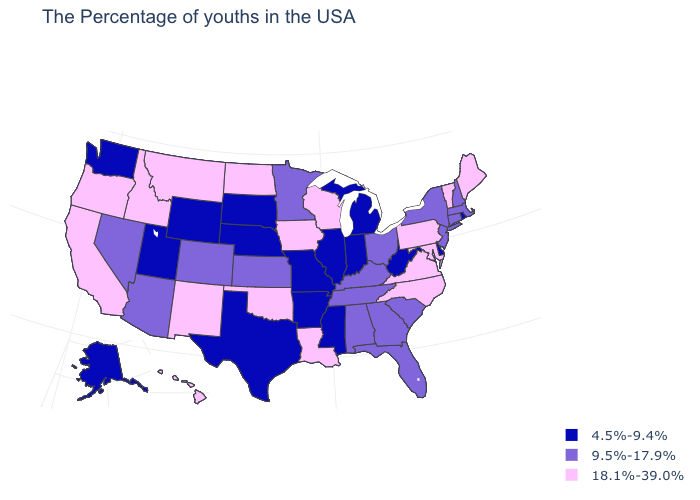Among the states that border Utah , which have the highest value?
Short answer required. New Mexico, Idaho. Among the states that border Connecticut , which have the highest value?
Give a very brief answer. Massachusetts, New York. Does the first symbol in the legend represent the smallest category?
Give a very brief answer. Yes. Does Georgia have a higher value than Nebraska?
Short answer required. Yes. Does Mississippi have the lowest value in the USA?
Answer briefly. Yes. Name the states that have a value in the range 9.5%-17.9%?
Write a very short answer. Massachusetts, New Hampshire, Connecticut, New York, New Jersey, South Carolina, Ohio, Florida, Georgia, Kentucky, Alabama, Tennessee, Minnesota, Kansas, Colorado, Arizona, Nevada. Does Wyoming have a lower value than Illinois?
Keep it brief. No. What is the highest value in states that border Mississippi?
Be succinct. 18.1%-39.0%. Does Illinois have the highest value in the USA?
Quick response, please. No. Name the states that have a value in the range 18.1%-39.0%?
Concise answer only. Maine, Vermont, Maryland, Pennsylvania, Virginia, North Carolina, Wisconsin, Louisiana, Iowa, Oklahoma, North Dakota, New Mexico, Montana, Idaho, California, Oregon, Hawaii. Name the states that have a value in the range 4.5%-9.4%?
Keep it brief. Rhode Island, Delaware, West Virginia, Michigan, Indiana, Illinois, Mississippi, Missouri, Arkansas, Nebraska, Texas, South Dakota, Wyoming, Utah, Washington, Alaska. How many symbols are there in the legend?
Quick response, please. 3. Among the states that border North Carolina , which have the lowest value?
Short answer required. South Carolina, Georgia, Tennessee. 